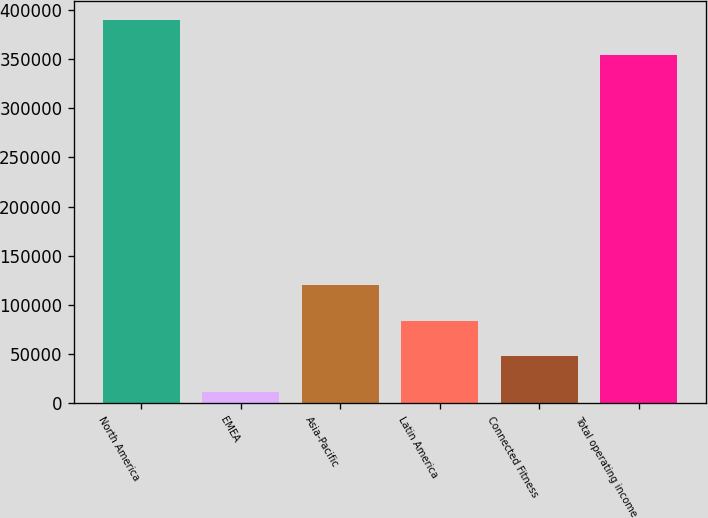Convert chart. <chart><loc_0><loc_0><loc_500><loc_500><bar_chart><fcel>North America<fcel>EMEA<fcel>Asia-Pacific<fcel>Latin America<fcel>Connected Fitness<fcel>Total operating income<nl><fcel>390013<fcel>11763<fcel>119938<fcel>83879.8<fcel>47821.4<fcel>353955<nl></chart> 